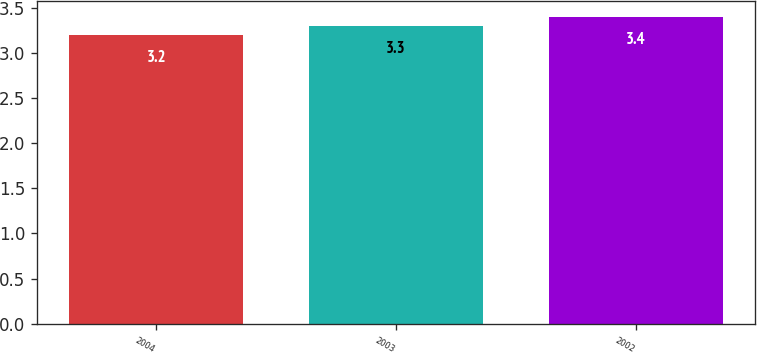Convert chart to OTSL. <chart><loc_0><loc_0><loc_500><loc_500><bar_chart><fcel>2004<fcel>2003<fcel>2002<nl><fcel>3.2<fcel>3.3<fcel>3.4<nl></chart> 